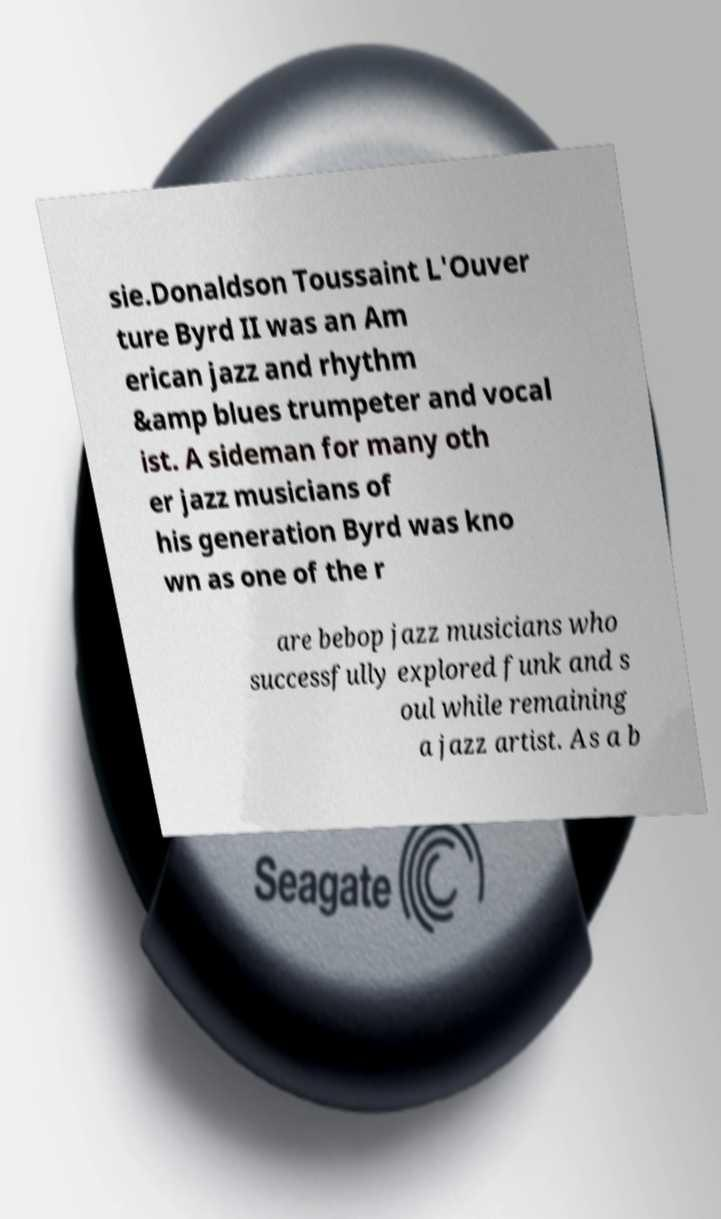Could you extract and type out the text from this image? sie.Donaldson Toussaint L'Ouver ture Byrd II was an Am erican jazz and rhythm &amp blues trumpeter and vocal ist. A sideman for many oth er jazz musicians of his generation Byrd was kno wn as one of the r are bebop jazz musicians who successfully explored funk and s oul while remaining a jazz artist. As a b 